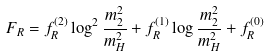Convert formula to latex. <formula><loc_0><loc_0><loc_500><loc_500>F _ { R } = f _ { R } ^ { ( 2 ) } \log ^ { 2 } \frac { m _ { 2 } ^ { 2 } } { m _ { H } ^ { 2 } } + f _ { R } ^ { ( 1 ) } \log \frac { m _ { 2 } ^ { 2 } } { m _ { H } ^ { 2 } } + f _ { R } ^ { ( 0 ) }</formula> 